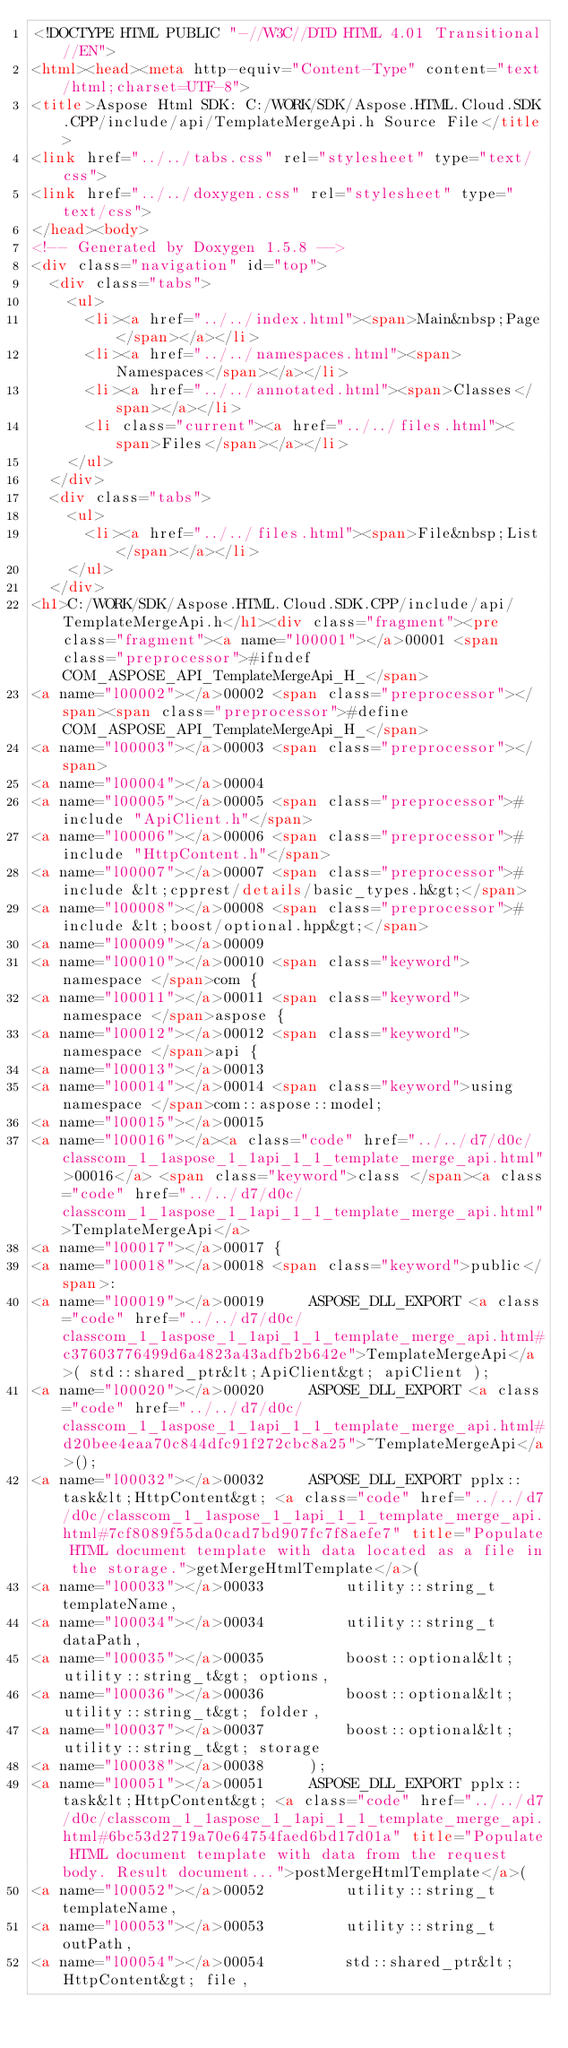Convert code to text. <code><loc_0><loc_0><loc_500><loc_500><_HTML_><!DOCTYPE HTML PUBLIC "-//W3C//DTD HTML 4.01 Transitional//EN">
<html><head><meta http-equiv="Content-Type" content="text/html;charset=UTF-8">
<title>Aspose Html SDK: C:/WORK/SDK/Aspose.HTML.Cloud.SDK.CPP/include/api/TemplateMergeApi.h Source File</title>
<link href="../../tabs.css" rel="stylesheet" type="text/css">
<link href="../../doxygen.css" rel="stylesheet" type="text/css">
</head><body>
<!-- Generated by Doxygen 1.5.8 -->
<div class="navigation" id="top">
  <div class="tabs">
    <ul>
      <li><a href="../../index.html"><span>Main&nbsp;Page</span></a></li>
      <li><a href="../../namespaces.html"><span>Namespaces</span></a></li>
      <li><a href="../../annotated.html"><span>Classes</span></a></li>
      <li class="current"><a href="../../files.html"><span>Files</span></a></li>
    </ul>
  </div>
  <div class="tabs">
    <ul>
      <li><a href="../../files.html"><span>File&nbsp;List</span></a></li>
    </ul>
  </div>
<h1>C:/WORK/SDK/Aspose.HTML.Cloud.SDK.CPP/include/api/TemplateMergeApi.h</h1><div class="fragment"><pre class="fragment"><a name="l00001"></a>00001 <span class="preprocessor">#ifndef COM_ASPOSE_API_TemplateMergeApi_H_</span>
<a name="l00002"></a>00002 <span class="preprocessor"></span><span class="preprocessor">#define COM_ASPOSE_API_TemplateMergeApi_H_</span>
<a name="l00003"></a>00003 <span class="preprocessor"></span>
<a name="l00004"></a>00004 
<a name="l00005"></a>00005 <span class="preprocessor">#include "ApiClient.h"</span>
<a name="l00006"></a>00006 <span class="preprocessor">#include "HttpContent.h"</span>
<a name="l00007"></a>00007 <span class="preprocessor">#include &lt;cpprest/details/basic_types.h&gt;</span>
<a name="l00008"></a>00008 <span class="preprocessor">#include &lt;boost/optional.hpp&gt;</span>
<a name="l00009"></a>00009 
<a name="l00010"></a>00010 <span class="keyword">namespace </span>com {
<a name="l00011"></a>00011 <span class="keyword">namespace </span>aspose {
<a name="l00012"></a>00012 <span class="keyword">namespace </span>api {
<a name="l00013"></a>00013 
<a name="l00014"></a>00014 <span class="keyword">using namespace </span>com::aspose::model;
<a name="l00015"></a>00015 
<a name="l00016"></a><a class="code" href="../../d7/d0c/classcom_1_1aspose_1_1api_1_1_template_merge_api.html">00016</a> <span class="keyword">class </span><a class="code" href="../../d7/d0c/classcom_1_1aspose_1_1api_1_1_template_merge_api.html">TemplateMergeApi</a>
<a name="l00017"></a>00017 {
<a name="l00018"></a>00018 <span class="keyword">public</span>:
<a name="l00019"></a>00019     ASPOSE_DLL_EXPORT <a class="code" href="../../d7/d0c/classcom_1_1aspose_1_1api_1_1_template_merge_api.html#c37603776499d6a4823a43adfb2b642e">TemplateMergeApi</a>( std::shared_ptr&lt;ApiClient&gt; apiClient );
<a name="l00020"></a>00020     ASPOSE_DLL_EXPORT <a class="code" href="../../d7/d0c/classcom_1_1aspose_1_1api_1_1_template_merge_api.html#d20bee4eaa70c844dfc91f272cbc8a25">~TemplateMergeApi</a>();
<a name="l00032"></a>00032     ASPOSE_DLL_EXPORT pplx::task&lt;HttpContent&gt; <a class="code" href="../../d7/d0c/classcom_1_1aspose_1_1api_1_1_template_merge_api.html#7cf8089f55da0cad7bd907fc7f8aefe7" title="Populate HTML document template with data located as a file in the storage.">getMergeHtmlTemplate</a>(
<a name="l00033"></a>00033         utility::string_t templateName,
<a name="l00034"></a>00034         utility::string_t dataPath,
<a name="l00035"></a>00035         boost::optional&lt;utility::string_t&gt; options,
<a name="l00036"></a>00036         boost::optional&lt;utility::string_t&gt; folder,
<a name="l00037"></a>00037         boost::optional&lt;utility::string_t&gt; storage
<a name="l00038"></a>00038     );
<a name="l00051"></a>00051     ASPOSE_DLL_EXPORT pplx::task&lt;HttpContent&gt; <a class="code" href="../../d7/d0c/classcom_1_1aspose_1_1api_1_1_template_merge_api.html#6bc53d2719a70e64754faed6bd17d01a" title="Populate HTML document template with data from the request body. Result document...">postMergeHtmlTemplate</a>(
<a name="l00052"></a>00052         utility::string_t templateName,
<a name="l00053"></a>00053         utility::string_t outPath,
<a name="l00054"></a>00054         std::shared_ptr&lt;HttpContent&gt; file,</code> 